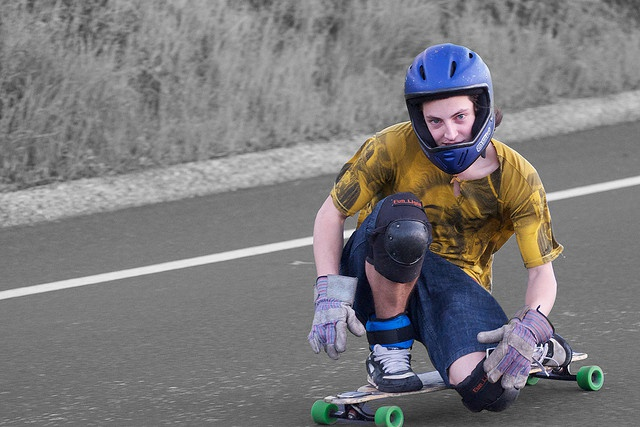Describe the objects in this image and their specific colors. I can see people in gray, black, navy, and darkgray tones and skateboard in gray, black, darkgray, and darkgreen tones in this image. 